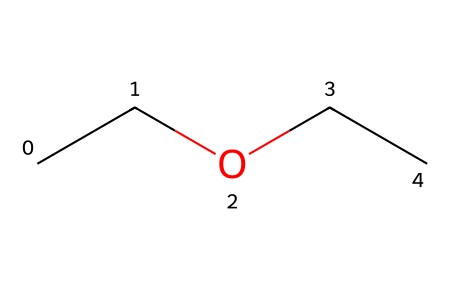What is the name of the chemical represented by this SMILES? The SMILES "CCOCC" corresponds to the structure of diethyl ether, which has two ethyl groups (C2H5) connected by an oxygen atom.
Answer: diethyl ether How many carbon atoms are present in this molecule? By analyzing the SMILES "CCOCC", we see two "CC" fragments, each representing an ethyl group with two carbon atoms, leading to a total of four carbon atoms in the molecule.
Answer: 4 How many oxygen atoms are in diethyl ether? In the SMILES "CCOCC", there is a single "O" which indicates there is one oxygen atom present in the chemical structure.
Answer: 1 What type of chemical bond connects the carbon atoms to the oxygen in this ether? The carbon atoms in diethyl ether are connected to the oxygen atom via single bonds, which are typical for ethers, characterized by carbon-oxygen single bonds.
Answer: single bond Is diethyl ether a polar or nonpolar compound? Diethyl ether has an ether functional group that creates a region of polarity due to the oxygen atom, but the overall structure remains largely nonpolar due to the predominance of carbon and hydrogen, leading to a nonpolar characteristic overall.
Answer: nonpolar What is the primary use of diethyl ether in sports medicine? Diethyl ether is primarily used as a solvent and anesthetic in medical applications; it can also provide quick pain relief through its anesthetic properties in some contexts.
Answer: pain relief 